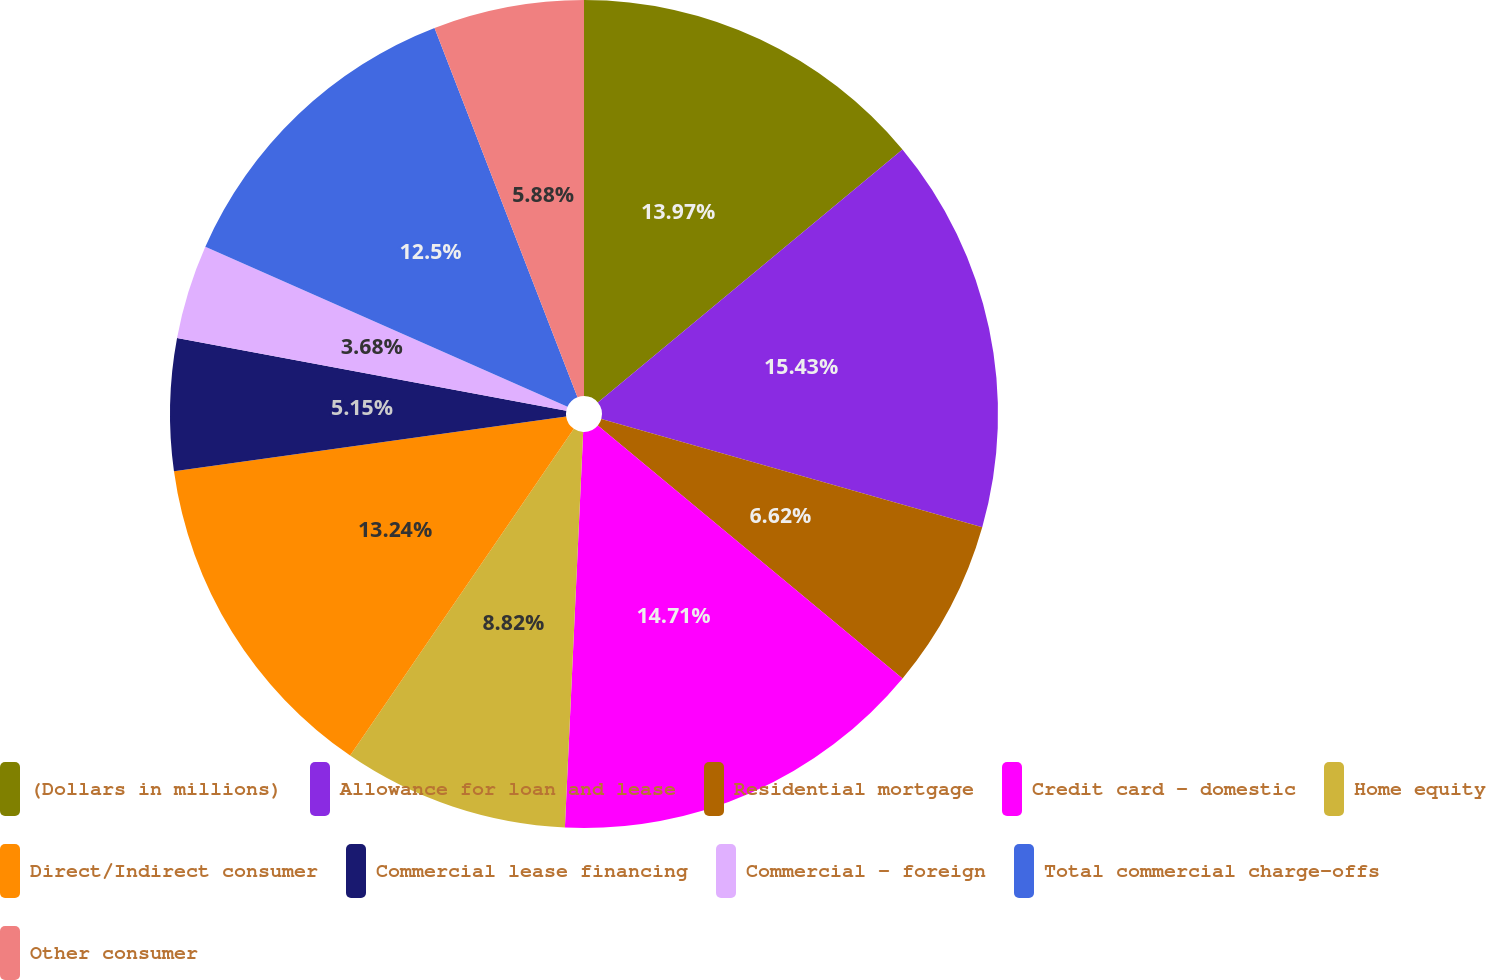<chart> <loc_0><loc_0><loc_500><loc_500><pie_chart><fcel>(Dollars in millions)<fcel>Allowance for loan and lease<fcel>Residential mortgage<fcel>Credit card - domestic<fcel>Home equity<fcel>Direct/Indirect consumer<fcel>Commercial lease financing<fcel>Commercial - foreign<fcel>Total commercial charge-offs<fcel>Other consumer<nl><fcel>13.97%<fcel>15.44%<fcel>6.62%<fcel>14.71%<fcel>8.82%<fcel>13.24%<fcel>5.15%<fcel>3.68%<fcel>12.5%<fcel>5.88%<nl></chart> 